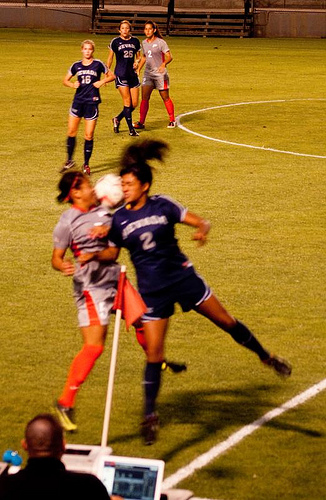<image>
Is there a shoe on the player? No. The shoe is not positioned on the player. They may be near each other, but the shoe is not supported by or resting on top of the player. Where is the flag in relation to the player? Is it behind the player? No. The flag is not behind the player. From this viewpoint, the flag appears to be positioned elsewhere in the scene. 